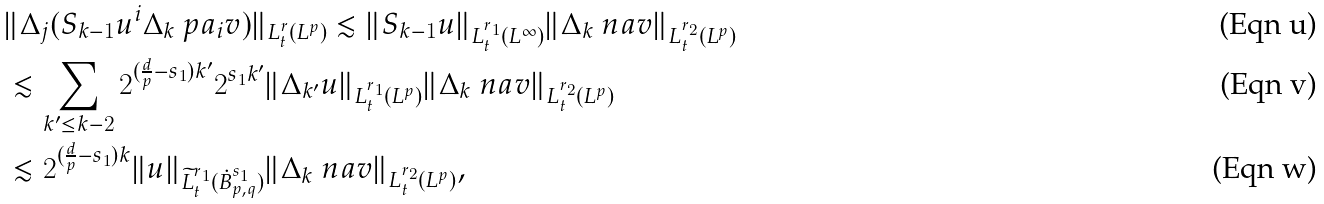<formula> <loc_0><loc_0><loc_500><loc_500>& \| \Delta _ { j } ( S _ { k - 1 } u ^ { i } \Delta _ { k } \ p a _ { i } v ) \| _ { L ^ { r } _ { t } ( L ^ { p } ) } \lesssim \| S _ { k - 1 } u \| _ { L ^ { r _ { 1 } } _ { t } ( L ^ { \infty } ) } \| \Delta _ { k } \ n a v \| _ { L ^ { r _ { 2 } } _ { t } ( L ^ { p } ) } \\ & \lesssim \sum _ { k ^ { \prime } \leq k - 2 } 2 ^ { ( \frac { d } { p } - s _ { 1 } ) k ^ { \prime } } 2 ^ { s _ { 1 } k ^ { \prime } } \| \Delta _ { k ^ { \prime } } u \| _ { L ^ { r _ { 1 } } _ { t } ( L ^ { p } ) } \| \Delta _ { k } \ n a v \| _ { L ^ { r _ { 2 } } _ { t } ( L ^ { p } ) } \\ & \lesssim 2 ^ { ( \frac { d } { p } - s _ { 1 } ) k } \| u \| _ { \widetilde { L } ^ { r _ { 1 } } _ { t } ( \dot { B } ^ { s _ { 1 } } _ { p , q } ) } \| \Delta _ { k } \ n a v \| _ { L ^ { r _ { 2 } } _ { t } ( L ^ { p } ) } ,</formula> 